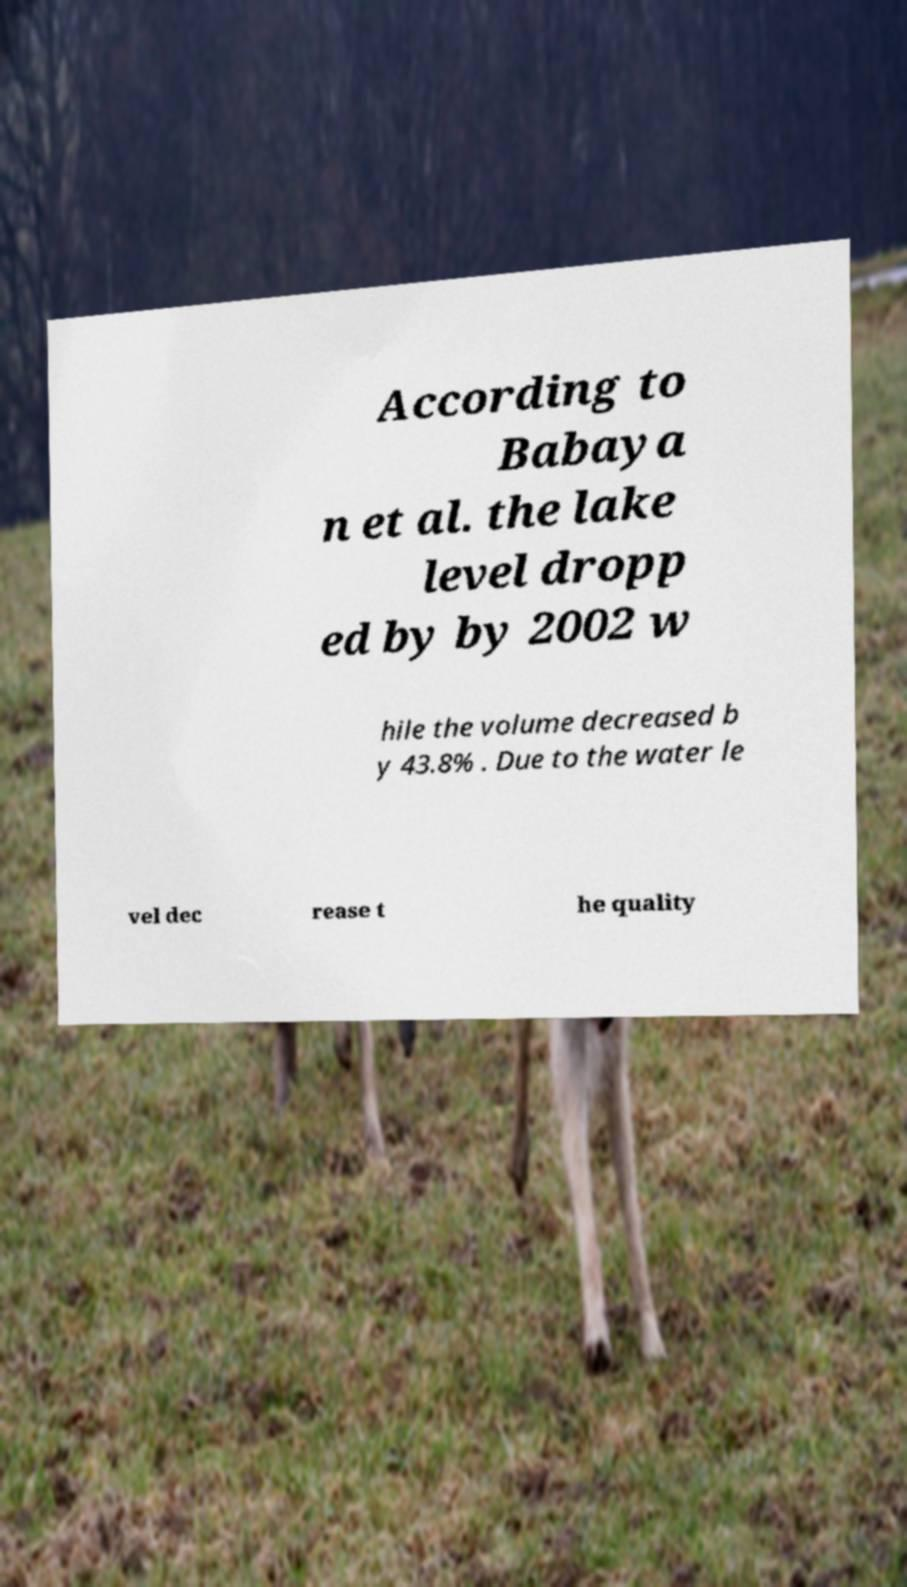I need the written content from this picture converted into text. Can you do that? According to Babaya n et al. the lake level dropp ed by by 2002 w hile the volume decreased b y 43.8% . Due to the water le vel dec rease t he quality 